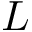<formula> <loc_0><loc_0><loc_500><loc_500>L</formula> 